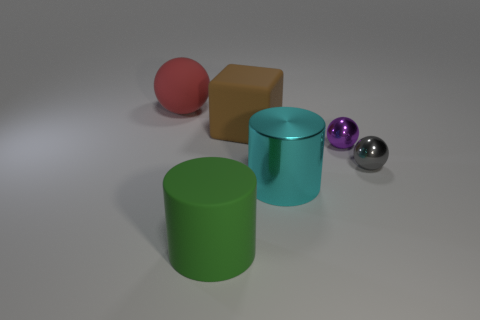Subtract all cyan balls. Subtract all yellow cylinders. How many balls are left? 3 Add 3 metal spheres. How many objects exist? 9 Subtract all cylinders. How many objects are left? 4 Add 4 big green shiny objects. How many big green shiny objects exist? 4 Subtract 0 blue cubes. How many objects are left? 6 Subtract all purple cylinders. Subtract all purple things. How many objects are left? 5 Add 4 red objects. How many red objects are left? 5 